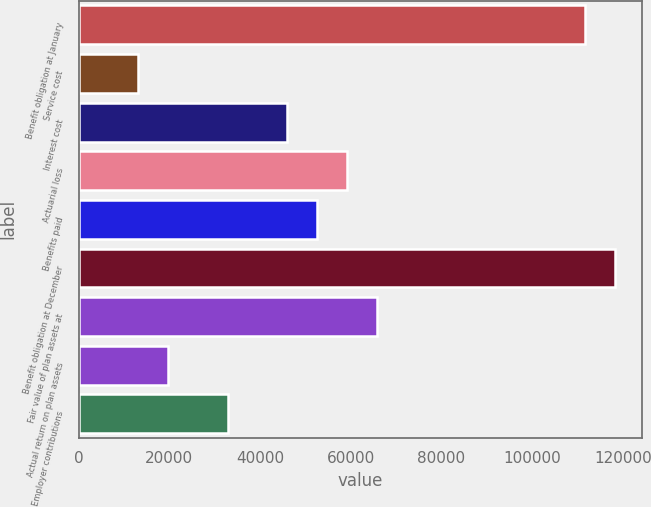Convert chart. <chart><loc_0><loc_0><loc_500><loc_500><bar_chart><fcel>Benefit obligation at January<fcel>Service cost<fcel>Interest cost<fcel>Actuarial loss<fcel>Benefits paid<fcel>Benefit obligation at December<fcel>Fair value of plan assets at<fcel>Actual return on plan assets<fcel>Employer contributions<nl><fcel>111754<fcel>13151<fcel>46018.5<fcel>59165.5<fcel>52592<fcel>118327<fcel>65739<fcel>19724.5<fcel>32871.5<nl></chart> 